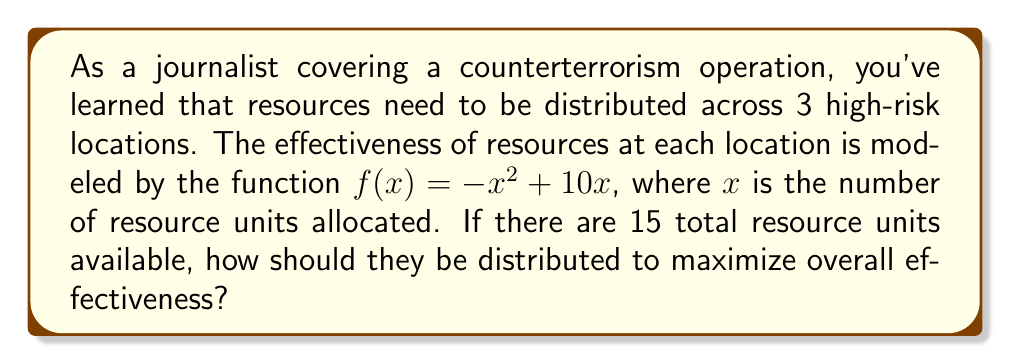Can you answer this question? 1) The effectiveness function for each location is $f(x) = -x^2 + 10x$.

2) We need to maximize the sum of effectiveness across all 3 locations:
   $F(x,y,z) = (-x^2 + 10x) + (-y^2 + 10y) + (-z^2 + 10z)$
   where $x$, $y$, and $z$ are the resources allocated to each location.

3) We have the constraint: $x + y + z = 15$ (total resources)

4) To maximize $F$, all partial derivatives should be equal:
   $\frac{\partial F}{\partial x} = \frac{\partial F}{\partial y} = \frac{\partial F}{\partial z}$

5) Calculate partial derivatives:
   $\frac{\partial F}{\partial x} = -2x + 10$
   $\frac{\partial F}{\partial y} = -2y + 10$
   $\frac{\partial F}{\partial z} = -2z + 10$

6) Set them equal:
   $-2x + 10 = -2y + 10 = -2z + 10$

7) This implies $x = y = z$

8) Given the constraint $x + y + z = 15$, we can conclude:
   $3x = 15$
   $x = 5$

9) Therefore, the optimal distribution is 5 units to each location.
Answer: 5 units to each location 